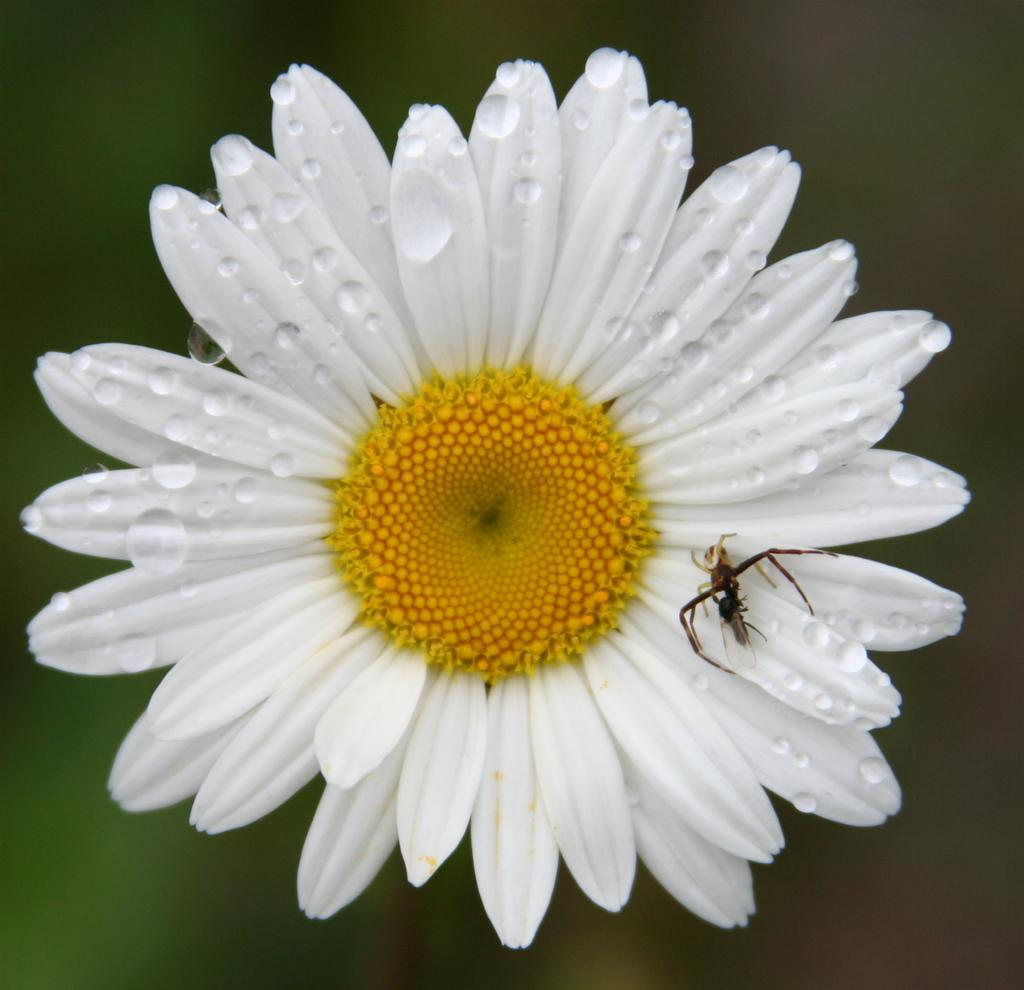What type of flower is in the image? There is a sunflower in the image. What is the color of the sunflower? The sunflower is white in color. Are there any other creatures or objects on the sunflower? Yes, there is an ant on the sunflower. How does the jellyfish interact with the sunflower in the image? There is no jellyfish present in the image, so it cannot interact with the sunflower. 